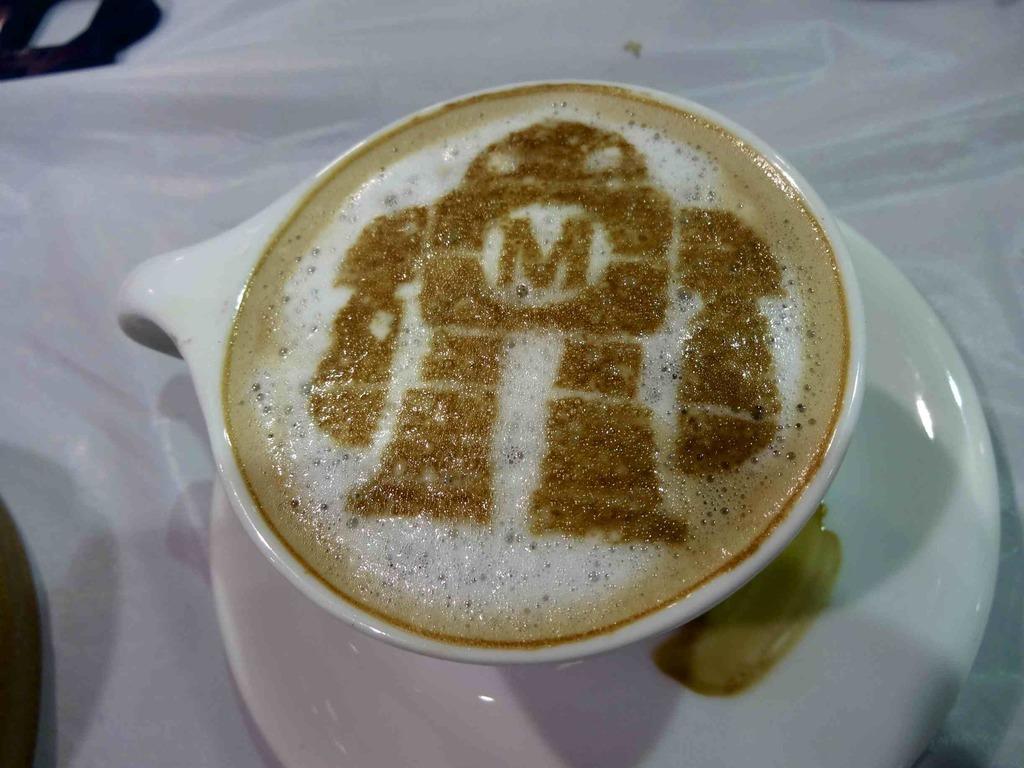Could you give a brief overview of what you see in this image? In this picture we can see the liquid, letter in the shape of a person in the cup. We can see other objects. 